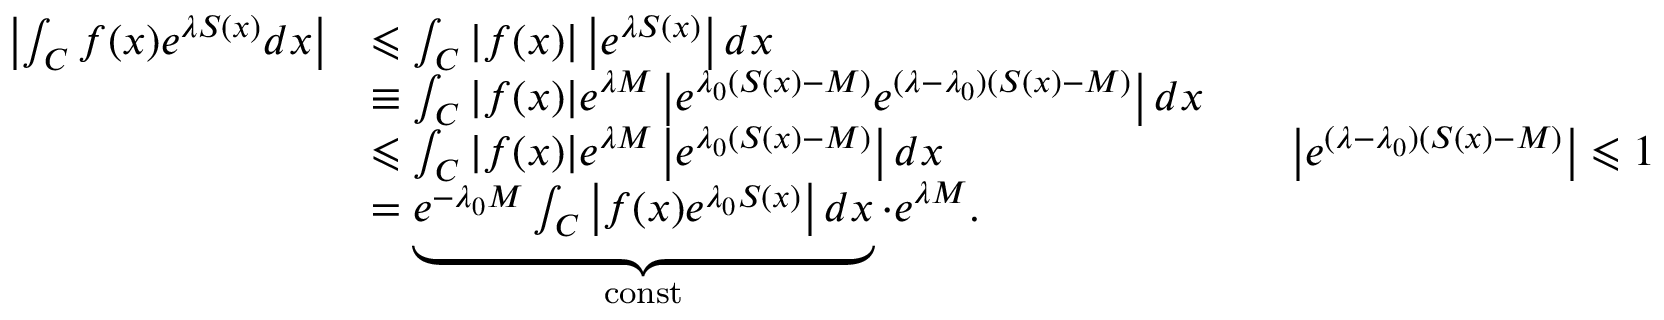<formula> <loc_0><loc_0><loc_500><loc_500>{ \begin{array} { r l r l } { \left | \int _ { C } f ( x ) e ^ { \lambda S ( x ) } d x \right | } & { \leqslant \int _ { C } | f ( x ) | \left | e ^ { \lambda S ( x ) } \right | d x } \\ & { \equiv \int _ { C } | f ( x ) | e ^ { \lambda M } \left | e ^ { \lambda _ { 0 } ( S ( x ) - M ) } e ^ { ( \lambda - \lambda _ { 0 } ) ( S ( x ) - M ) } \right | d x } \\ & { \leqslant \int _ { C } | f ( x ) | e ^ { \lambda M } \left | e ^ { \lambda _ { 0 } ( S ( x ) - M ) } \right | d x } & & { \left | e ^ { ( \lambda - \lambda _ { 0 } ) ( S ( x ) - M ) } \right | \leqslant 1 } \\ & { = \underbrace { e ^ { - \lambda _ { 0 } M } \int _ { C } \left | f ( x ) e ^ { \lambda _ { 0 } S ( x ) } \right | d x } _ { c o n s t } \cdot e ^ { \lambda M } . } \end{array} }</formula> 